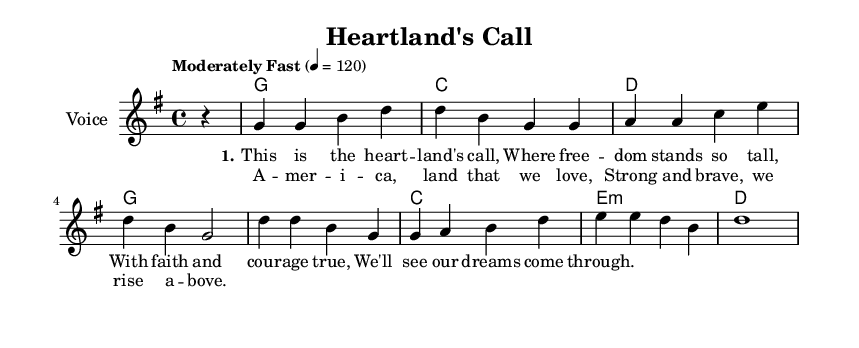What is the key signature of this music? The key signature is G major, indicated by one sharp (F#) and is seen in the \key g \major command in the global section.
Answer: G major What is the time signature of this piece? The time signature is 4/4, which is signified by the \time 4/4 command present in the global section, indicating four beats per measure.
Answer: 4/4 What is the tempo marking for this piece? The tempo marking indicates "Moderately Fast" and corresponds to a metronome marking of 120 beats per minute, specified in the global section.
Answer: Moderately Fast 120 How many measures are in the melody? By counting the segments defined by the vertical lines in the melody section, there are 8 measures present, as each measure contains a group of music notes separated by bar lines.
Answer: 8 What is the primary theme expressed in the lyrics? The primary theme expressed in the lyrics centers around patriotism and appreciation for freedom, as highlighted in phrases like "Where freedom stands so tall" and "America, land that we love."
Answer: Patriotism Which chord appears most frequently throughout the piece? The chord G appears most frequently in the harmonies section, listed as the first and fifth chords, indicating its important role in the music progression.
Answer: G What type of music does this anthem represent? This piece represents a Country Rock anthem, as indicated by its musical elements and the lyrical content celebrating American values, a style characteristic of the genre.
Answer: Country Rock 